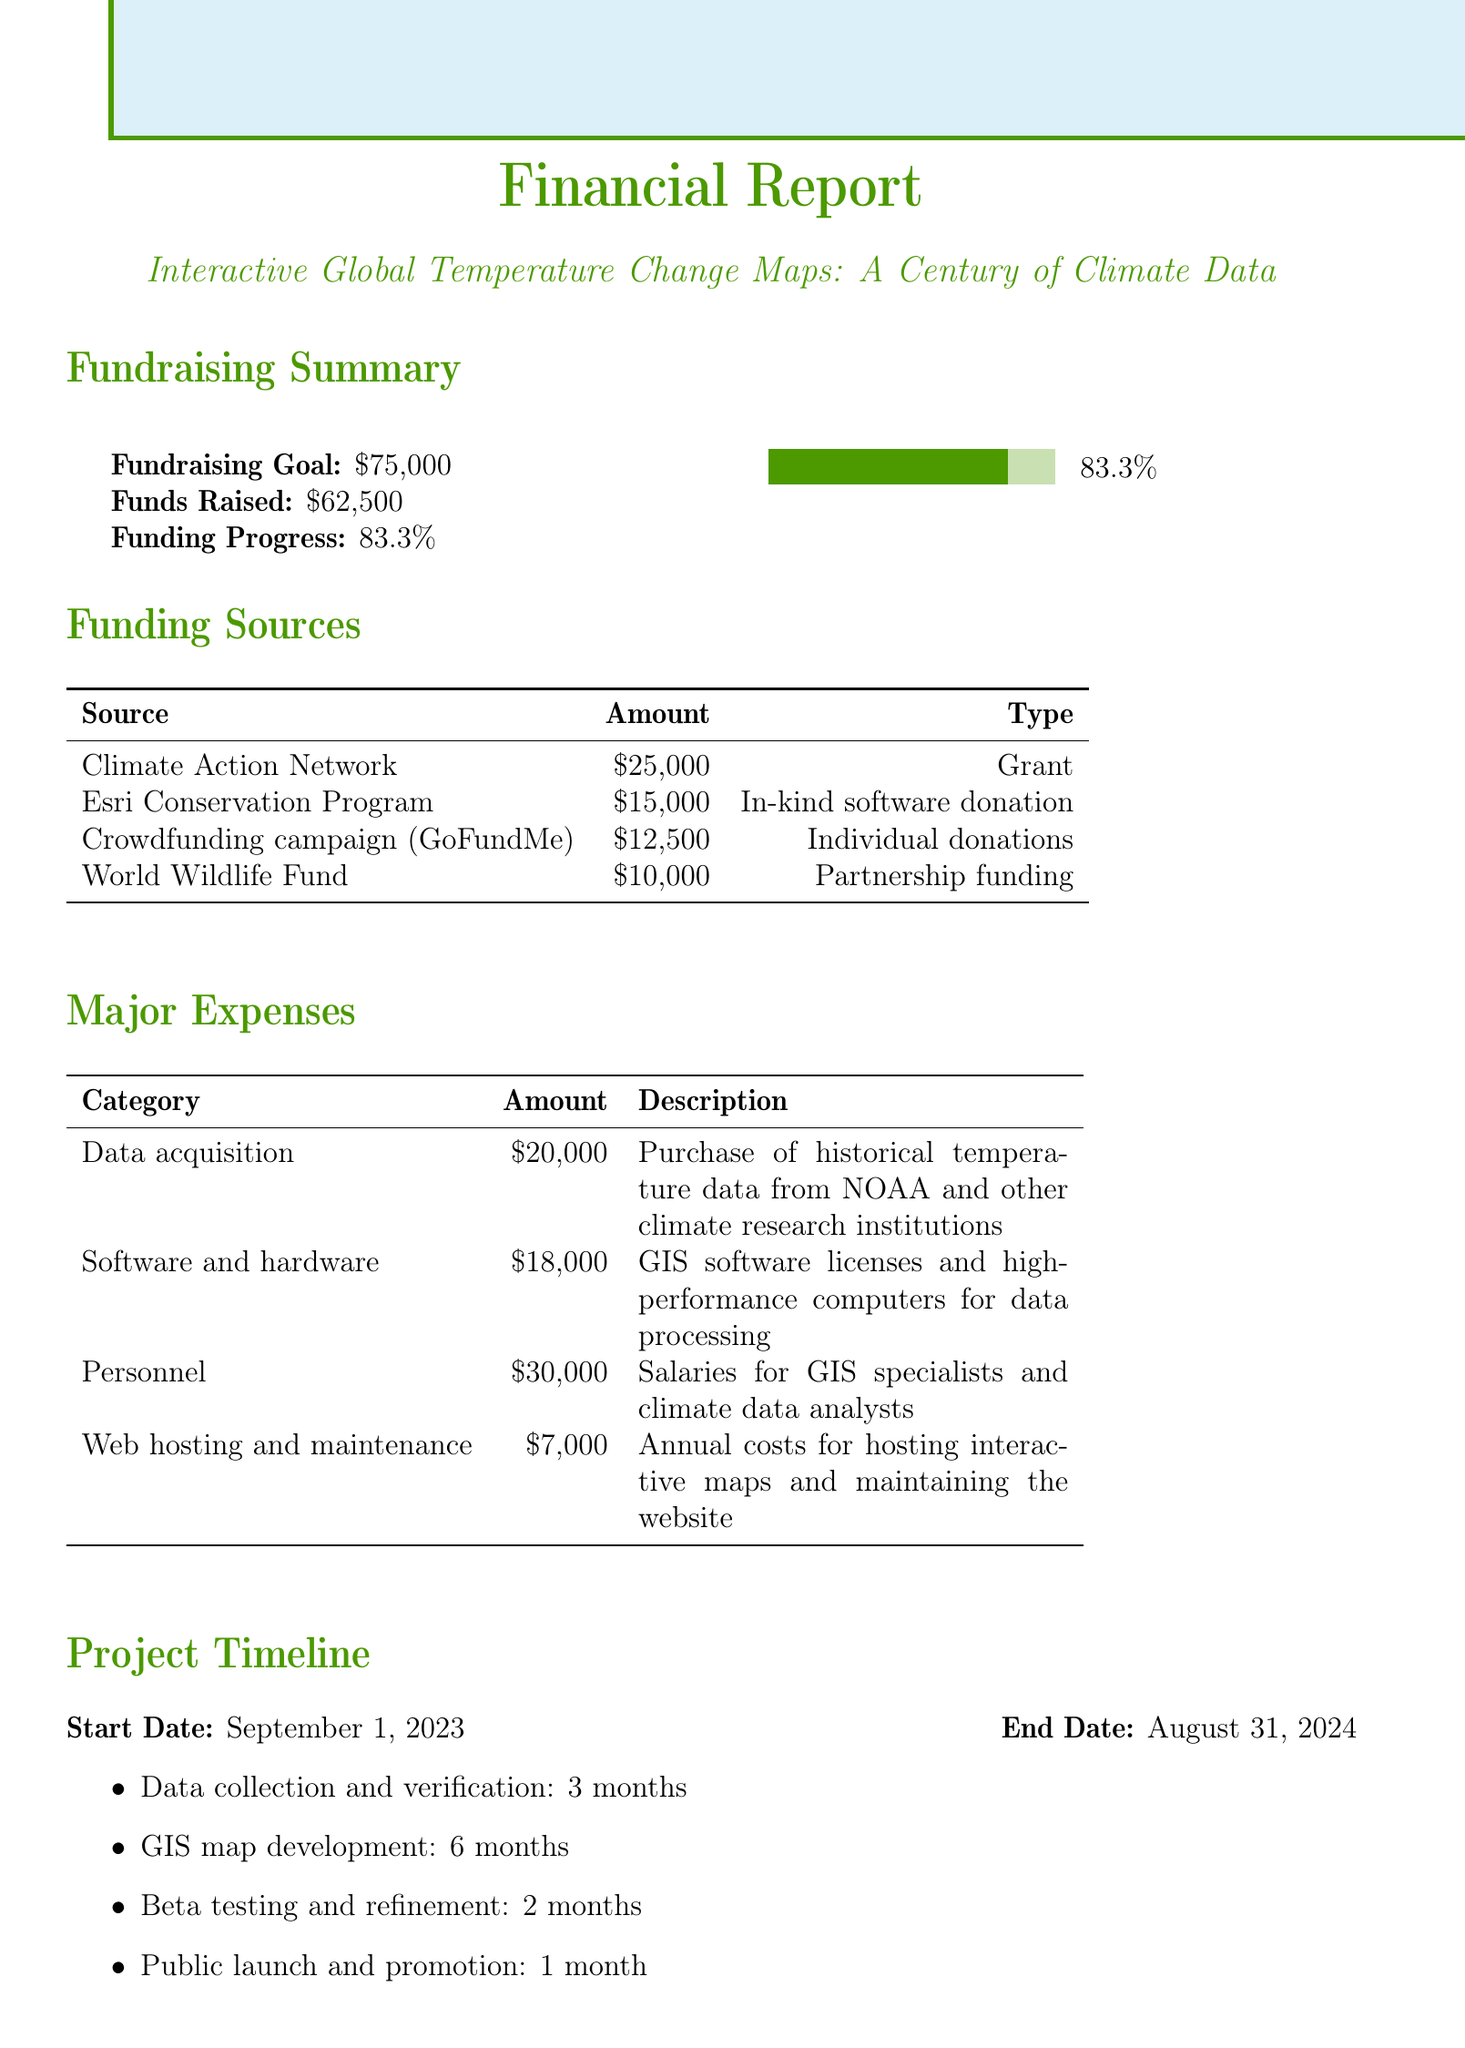what is the fundraising goal? The fundraising goal is specifically mentioned in the document as the amount the project aims to raise.
Answer: $75,000 how much has been raised so far? The document states the amount of funds that have already been raised for the project.
Answer: $62,500 who provided the largest funding source? The funding source with the highest amount is listed in the funding sources section of the document.
Answer: Climate Action Network what is the total amount spent on personnel? The personnel expenses are included in the major expenses section, indicating how much has been allocated for salaries.
Answer: $30,000 how many months is the GIS map development scheduled to take? The project timeline outlines how many months are allocated for the development of the GIS maps.
Answer: 6 months what type of donation did the Esri Conservation Program provide? The type of funding by the Esri Conservation Program is specified in the funding sources table.
Answer: In-kind software donation what will the interactive GIS platform showcase? The expected outcomes describe what the resulting platform will display.
Answer: global temperature changes from 1920 to 2020 how will annual updates be funded? The sustainability plan in the document explains how future updates for the project will be financed.
Answer: partnerships with environmental organizations and academic institutions 